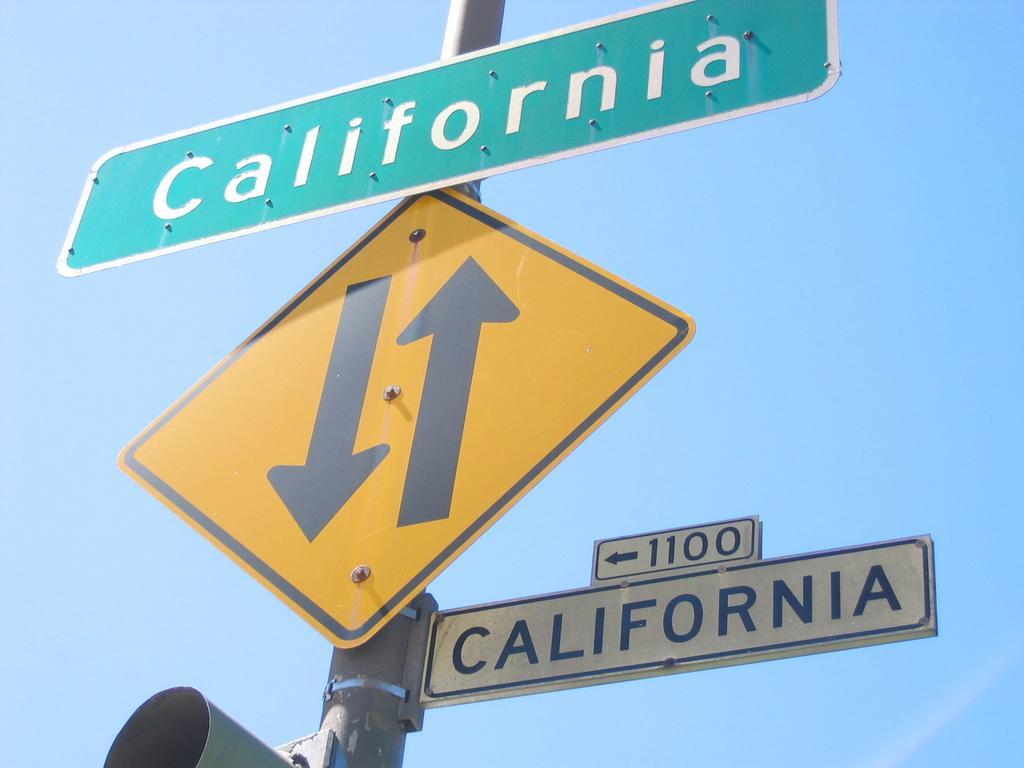How would you summarize this image in a sentence or two? In the middle of this image, there are three sign boards, which are in green, yellow and white color respectively attached to a pole. In the background, there are clouds in the blue sky. 